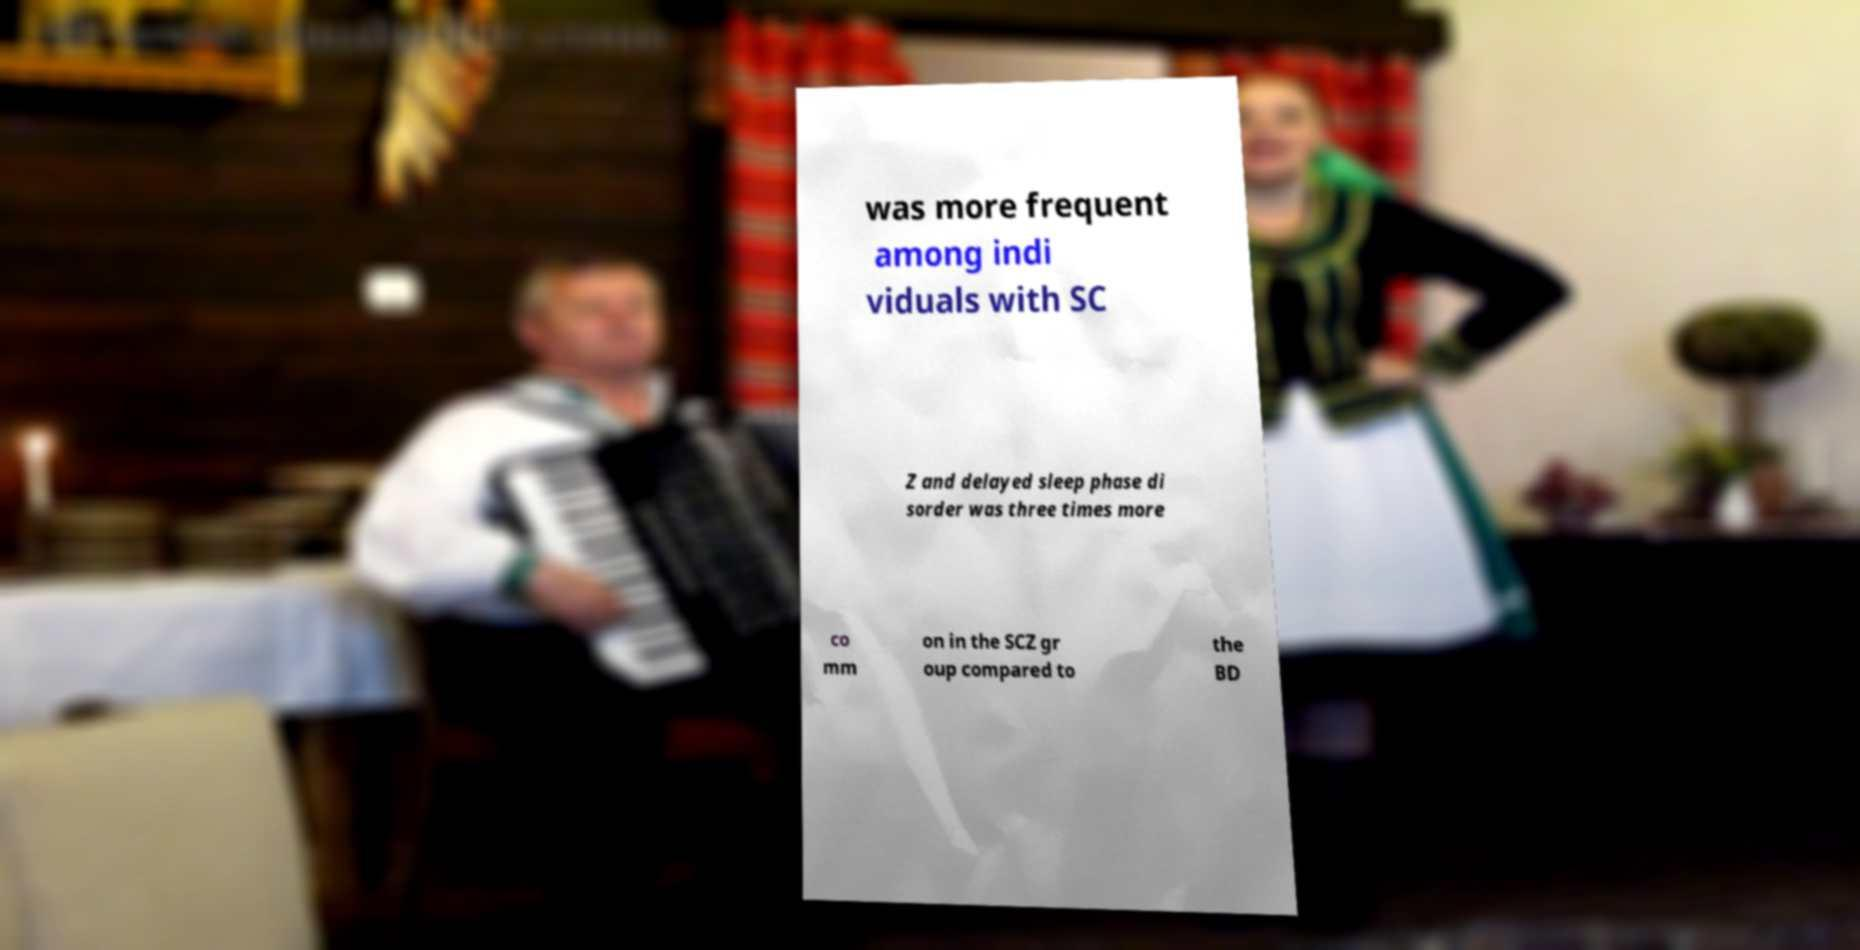Can you accurately transcribe the text from the provided image for me? was more frequent among indi viduals with SC Z and delayed sleep phase di sorder was three times more co mm on in the SCZ gr oup compared to the BD 